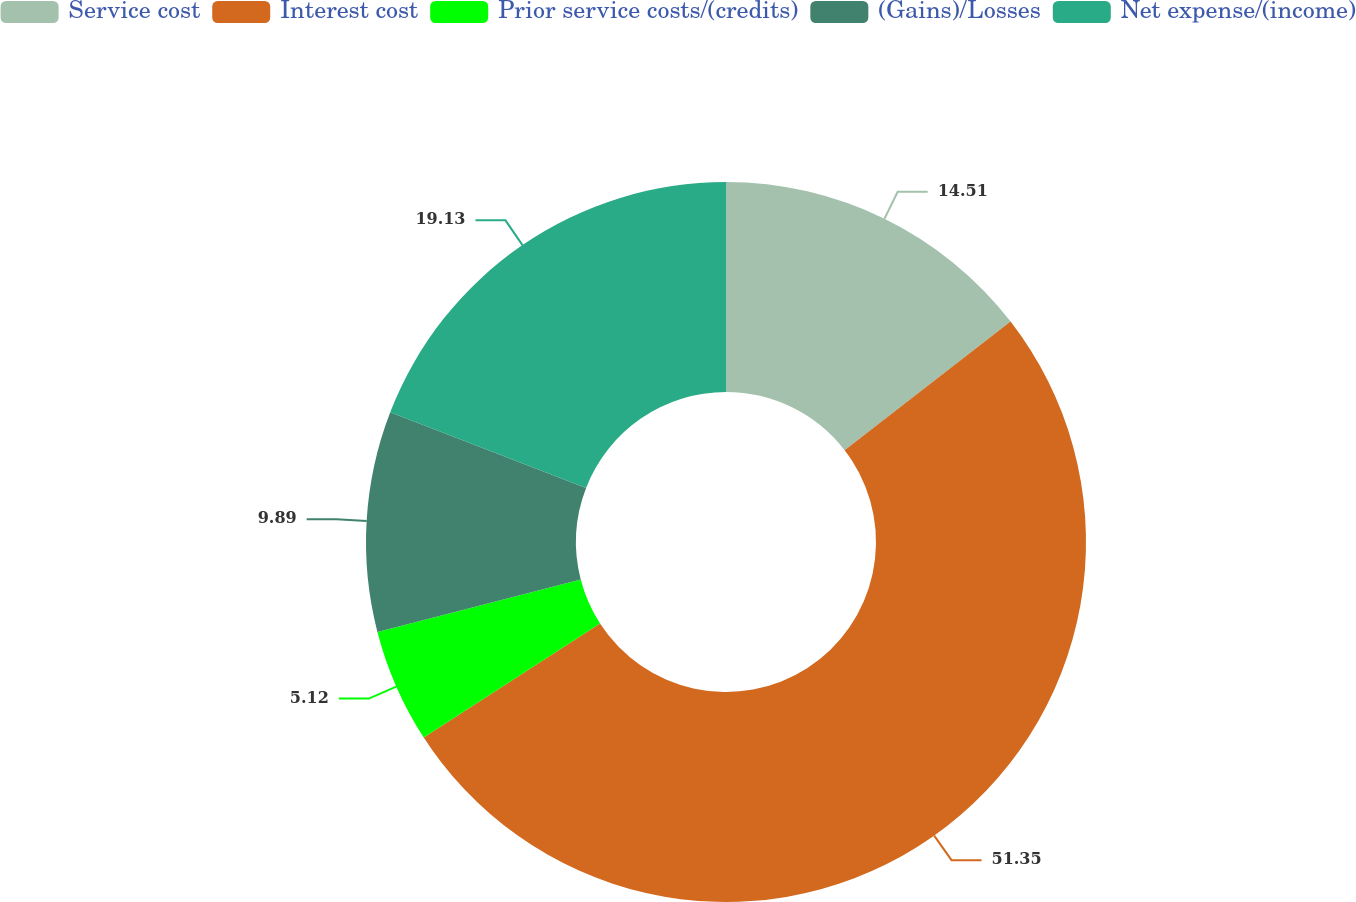Convert chart. <chart><loc_0><loc_0><loc_500><loc_500><pie_chart><fcel>Service cost<fcel>Interest cost<fcel>Prior service costs/(credits)<fcel>(Gains)/Losses<fcel>Net expense/(income)<nl><fcel>14.51%<fcel>51.36%<fcel>5.12%<fcel>9.89%<fcel>19.13%<nl></chart> 